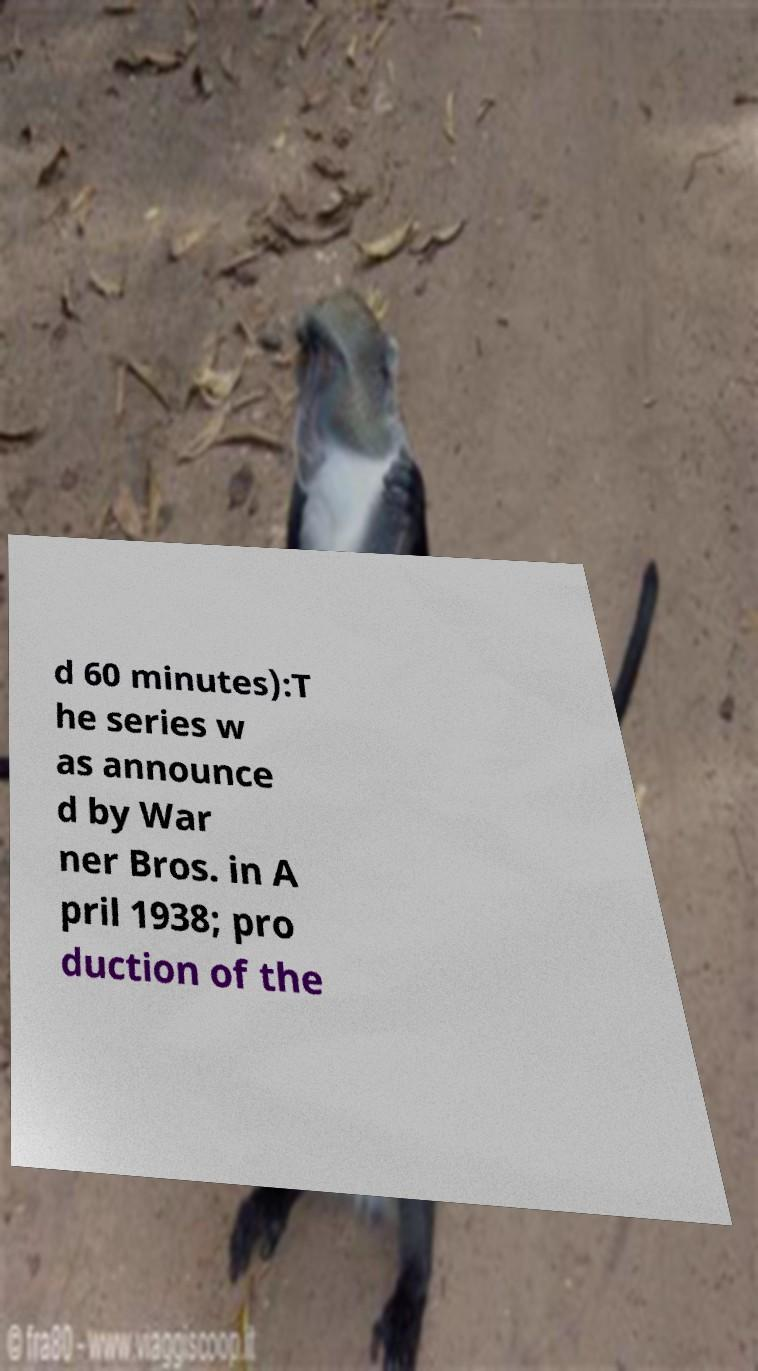What messages or text are displayed in this image? I need them in a readable, typed format. d 60 minutes):T he series w as announce d by War ner Bros. in A pril 1938; pro duction of the 